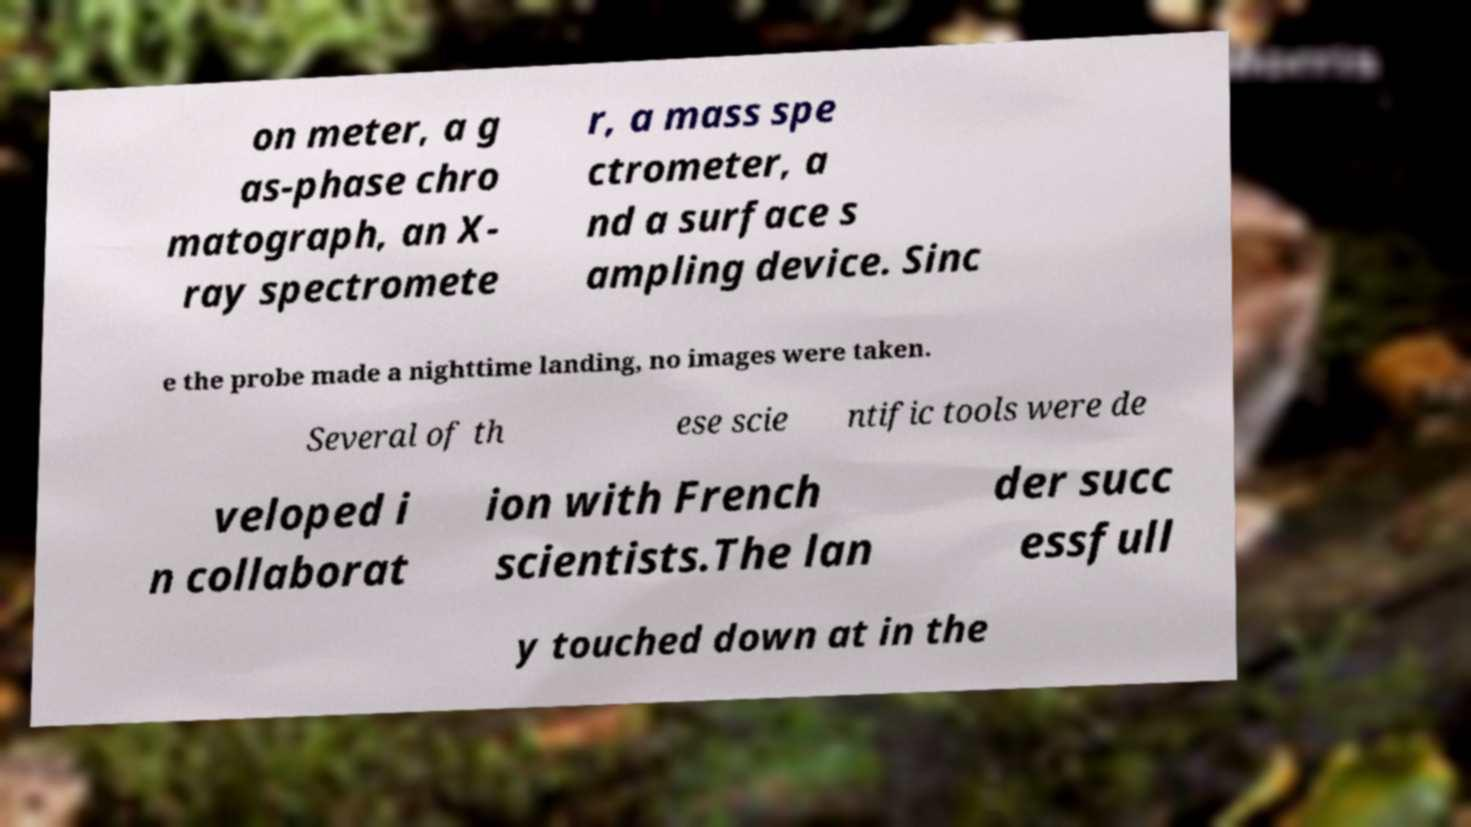Could you extract and type out the text from this image? on meter, a g as-phase chro matograph, an X- ray spectromete r, a mass spe ctrometer, a nd a surface s ampling device. Sinc e the probe made a nighttime landing, no images were taken. Several of th ese scie ntific tools were de veloped i n collaborat ion with French scientists.The lan der succ essfull y touched down at in the 